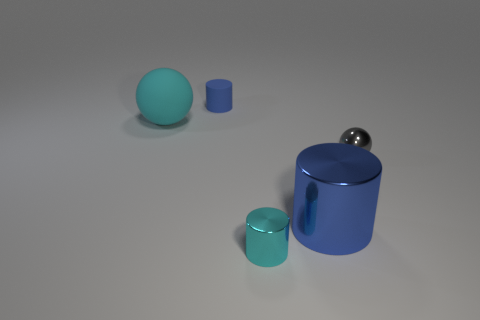Add 3 green rubber things. How many objects exist? 8 Subtract all cylinders. How many objects are left? 2 Add 5 small metallic things. How many small metallic things are left? 7 Add 4 brown metallic things. How many brown metallic things exist? 4 Subtract 0 red cylinders. How many objects are left? 5 Subtract all large yellow rubber cylinders. Subtract all tiny spheres. How many objects are left? 4 